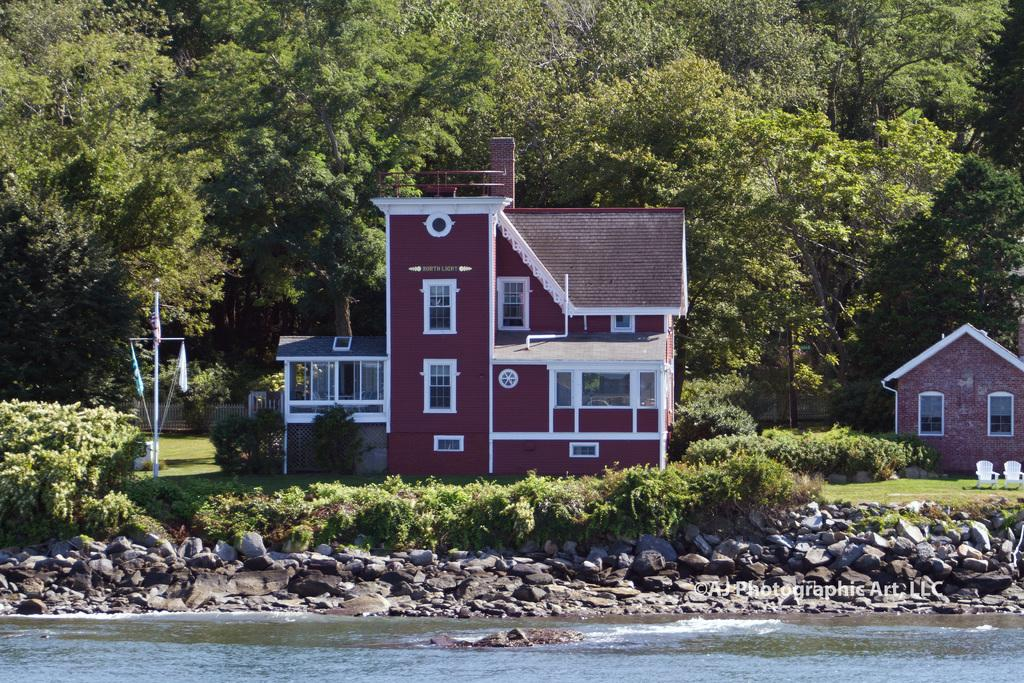What is the color of the building in the image? The building in the image is maroon in color. Can you describe the other building in the image? There is another building at the right side of the image. What type of vegetation can be seen in the background of the image? There are trees in green color in the background of the image. What type of material is visible in the image? There are stones visible in the image. What natural element is present in the image? There is water in the image. Can you taste the butter in the image? There is no butter present in the image. 